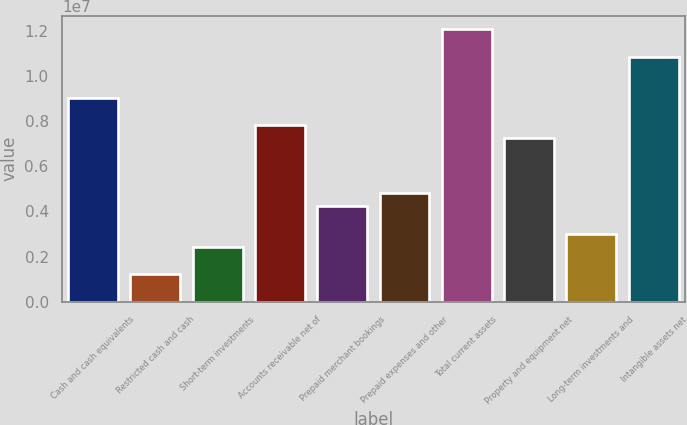<chart> <loc_0><loc_0><loc_500><loc_500><bar_chart><fcel>Cash and cash equivalents<fcel>Restricted cash and cash<fcel>Short-term investments<fcel>Accounts receivable net of<fcel>Prepaid merchant bookings<fcel>Prepaid expenses and other<fcel>Total current assets<fcel>Property and equipment net<fcel>Long-term investments and<fcel>Intangible assets net<nl><fcel>9.05123e+06<fcel>1.20685e+06<fcel>2.41368e+06<fcel>7.84441e+06<fcel>4.22392e+06<fcel>4.82734e+06<fcel>1.20683e+07<fcel>7.24099e+06<fcel>3.0171e+06<fcel>1.08615e+07<nl></chart> 